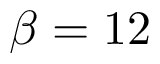Convert formula to latex. <formula><loc_0><loc_0><loc_500><loc_500>\beta = 1 2</formula> 